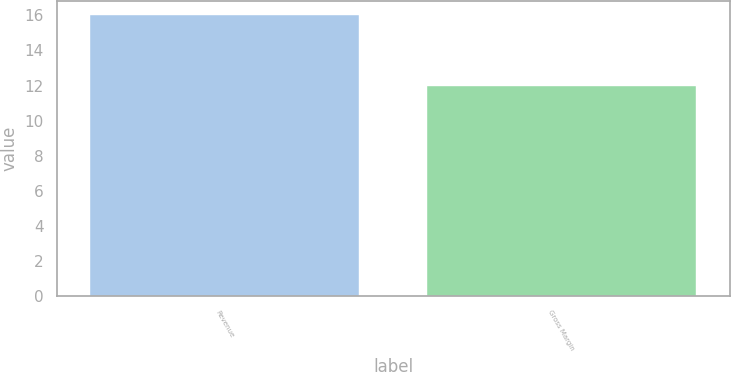<chart> <loc_0><loc_0><loc_500><loc_500><bar_chart><fcel>Revenue<fcel>Gross Margin<nl><fcel>16<fcel>12<nl></chart> 